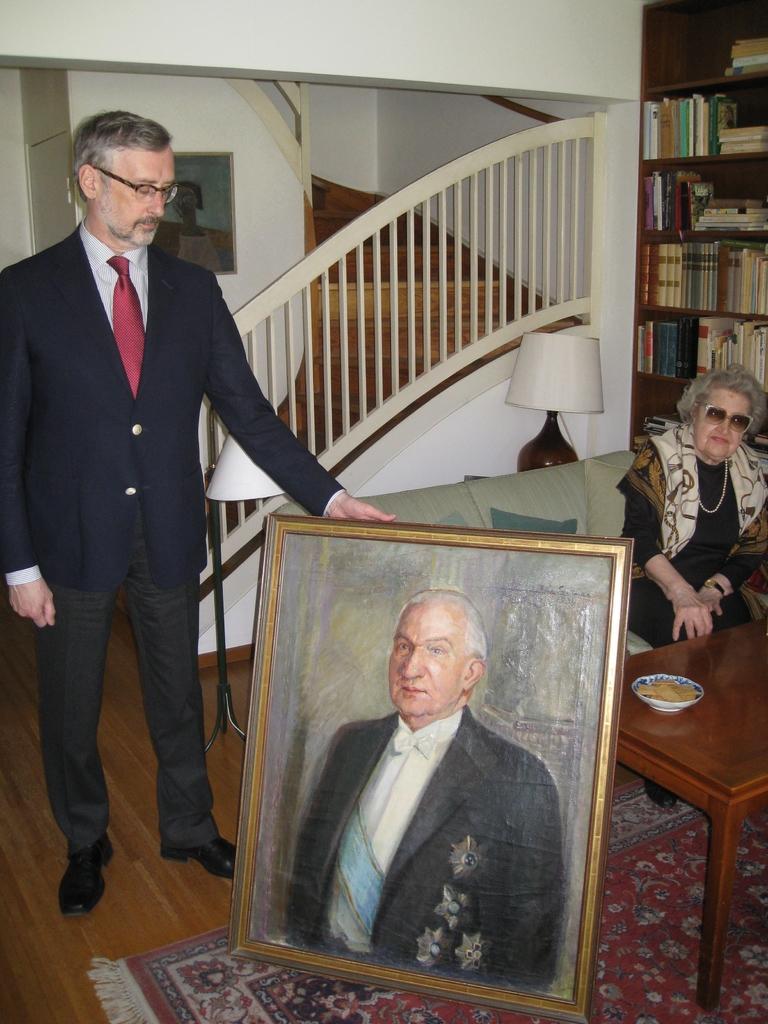How would you summarize this image in a sentence or two? In the image I can see a woman is sitting on the sofa and a man is standing on the floor and holding a photo frame which is on the floor. In the photo frame I can see a painting of a man. In the background I can see a light lamp, shelf which has books, staircase, a table and some other objects. 